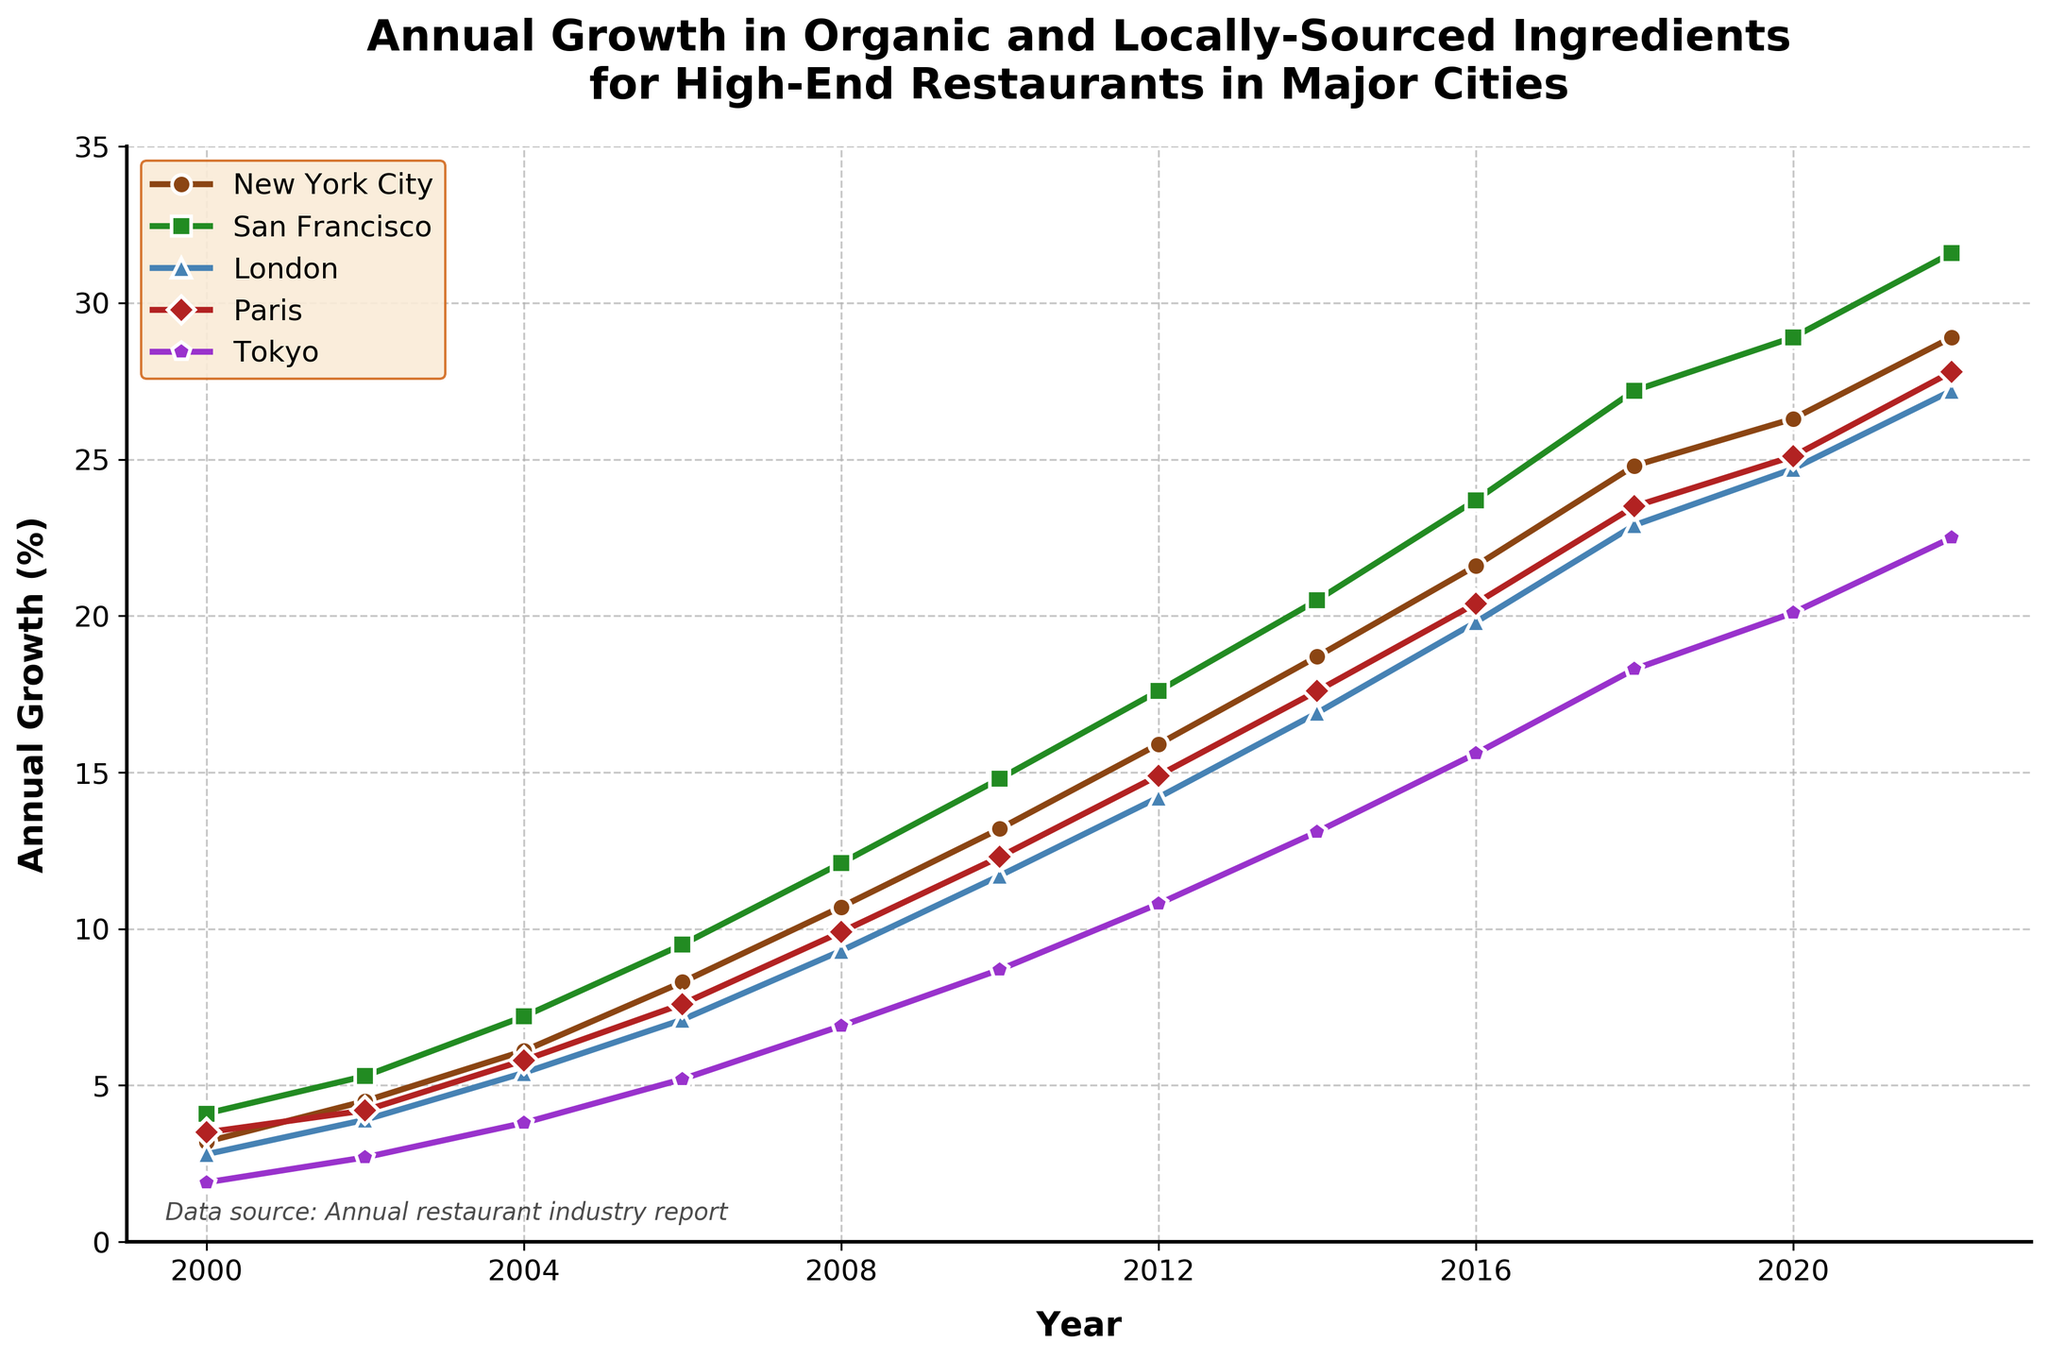What trend can be observed in the annual growth of organic and locally-sourced ingredient availability for high-end restaurants in New York City from 2000 to 2022? New York City shows a consistent upward trend in the annual growth of organic and locally-sourced ingredient availability from 3.2% in 2000 to 28.9% in 2022.
Answer: Consistent upward trend Comparing the data from 2000 and 2022, which city had the highest percentage change in the availability of organic and locally-sourced ingredients? San Francisco had the highest percentage change. In 2000, it was 4.1%, and in 2022, it reached 31.6%. The change is 31.6% - 4.1% = 27.5%.
Answer: San Francisco What year did Tokyo surpass 10% in annual growth for the first time? Tokyo surpassed 10% in 2012 when its growth reached 10.8%.
Answer: 2012 Which city showed the greatest increase in organic and locally-sourced ingredient availability between 2010 and 2018? Comparing the values, San Francisco increased from 14.8% in 2010 to 27.2% in 2018, which is an increase of 27.2% - 14.8% = 12.4%.
Answer: San Francisco How does the annual growth trend in Paris in 2016 compare to that in 2006? In 2006, Paris had 7.6% and in 2016, it had 20.4%. The growth in 2016 is much higher compared to 2006.
Answer: Much higher in 2016 What is the average annual growth in organic and locally-sourced ingredients for London from 2000 to 2022? Sum the values for London from 2000 to 2022 and divide by the number of values: (2.8 + 3.9 + 5.4 + 7.1 + 9.3 + 11.7 + 14.2 + 16.9 + 19.8 + 22.9 + 24.7 + 27.2) / 12 = 13.15%.
Answer: 13.15% Which city's trend line is represented by the color green? By referring to the visual attributes, the green line represents San Francisco.
Answer: San Francisco Among the five cities, which one had the lowest growth rate in 2004 and what was the percentage? In 2004, Tokyo had the lowest growth rate at 3.8%.
Answer: Tokyo with 3.8% What is the difference in growth rates between New York City and Paris in 2020? New York City had 26.3% and Paris had 25.1% in 2020. The difference is 26.3% - 25.1% = 1.2%.
Answer: 1.2% 